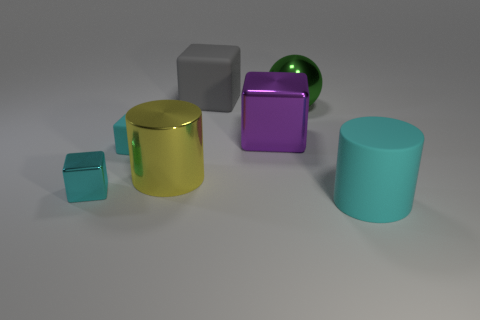Is there any other thing that has the same shape as the large green shiny thing?
Keep it short and to the point. No. What number of big balls are the same material as the yellow cylinder?
Offer a terse response. 1. Are there fewer big spheres than tiny purple matte cylinders?
Ensure brevity in your answer.  No. Is the block that is behind the large ball made of the same material as the big yellow thing?
Keep it short and to the point. No. What number of balls are either big purple things or big gray rubber things?
Provide a succinct answer. 0. There is a matte thing that is both to the right of the large yellow cylinder and in front of the big gray object; what is its shape?
Your answer should be very brief. Cylinder. What color is the metal cube that is behind the big cylinder that is behind the large matte thing in front of the small cyan metallic block?
Your answer should be very brief. Purple. Is the number of tiny rubber objects behind the big yellow shiny cylinder less than the number of green shiny cylinders?
Your response must be concise. No. Is the shape of the tiny cyan thing that is on the left side of the tiny matte block the same as the matte thing on the left side of the yellow cylinder?
Give a very brief answer. Yes. What number of objects are either big rubber things behind the yellow metallic cylinder or large gray things?
Offer a very short reply. 1. 